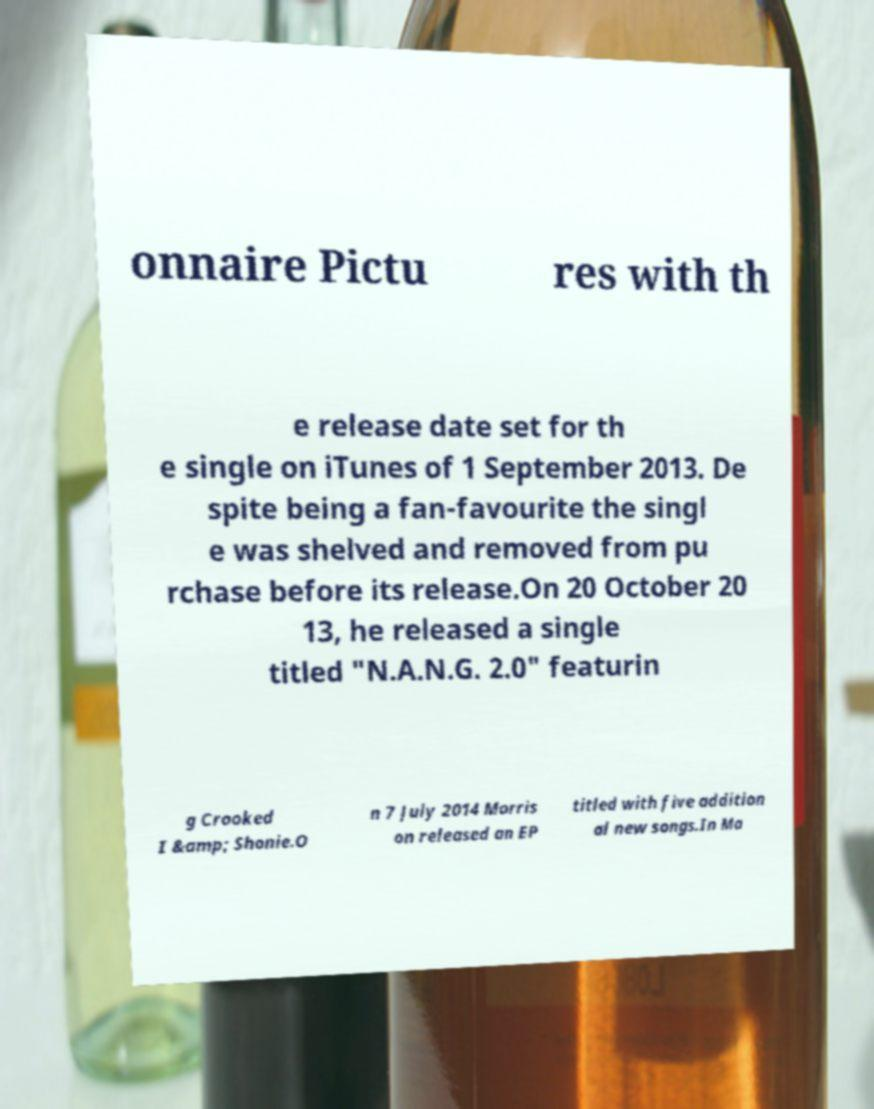Please read and relay the text visible in this image. What does it say? onnaire Pictu res with th e release date set for th e single on iTunes of 1 September 2013. De spite being a fan-favourite the singl e was shelved and removed from pu rchase before its release.On 20 October 20 13, he released a single titled "N.A.N.G. 2.0" featurin g Crooked I &amp; Shonie.O n 7 July 2014 Morris on released an EP titled with five addition al new songs.In Ma 